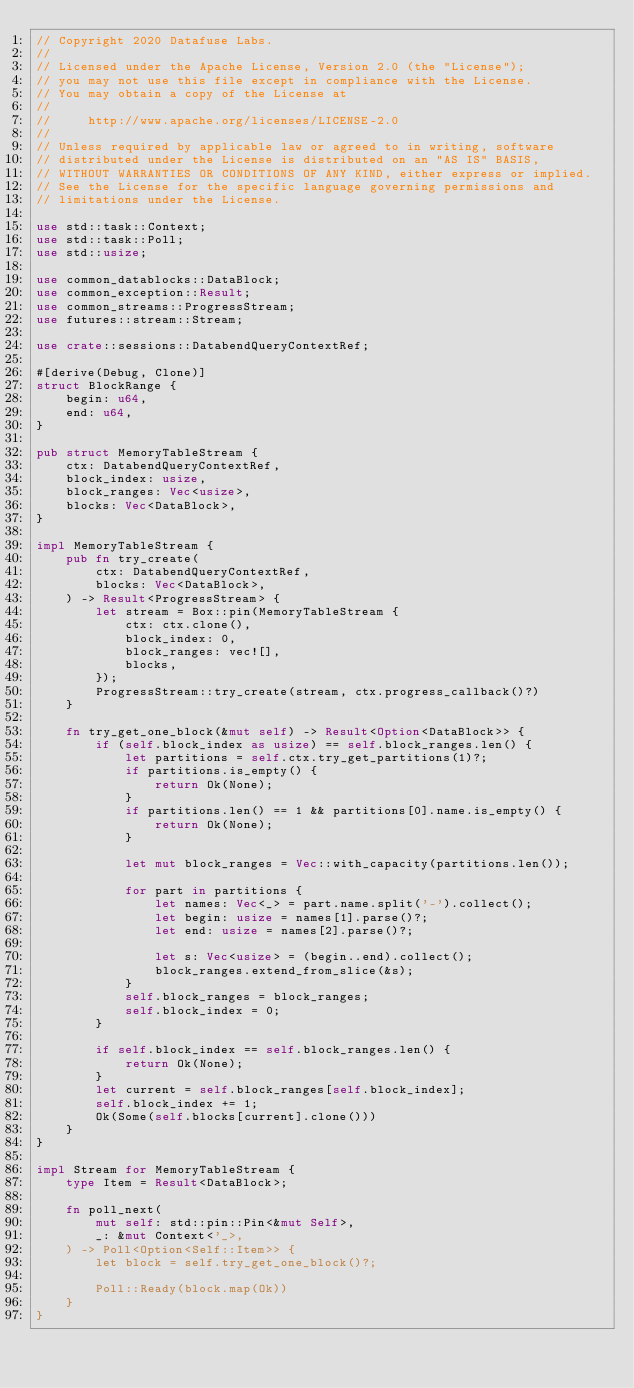Convert code to text. <code><loc_0><loc_0><loc_500><loc_500><_Rust_>// Copyright 2020 Datafuse Labs.
//
// Licensed under the Apache License, Version 2.0 (the "License");
// you may not use this file except in compliance with the License.
// You may obtain a copy of the License at
//
//     http://www.apache.org/licenses/LICENSE-2.0
//
// Unless required by applicable law or agreed to in writing, software
// distributed under the License is distributed on an "AS IS" BASIS,
// WITHOUT WARRANTIES OR CONDITIONS OF ANY KIND, either express or implied.
// See the License for the specific language governing permissions and
// limitations under the License.

use std::task::Context;
use std::task::Poll;
use std::usize;

use common_datablocks::DataBlock;
use common_exception::Result;
use common_streams::ProgressStream;
use futures::stream::Stream;

use crate::sessions::DatabendQueryContextRef;

#[derive(Debug, Clone)]
struct BlockRange {
    begin: u64,
    end: u64,
}

pub struct MemoryTableStream {
    ctx: DatabendQueryContextRef,
    block_index: usize,
    block_ranges: Vec<usize>,
    blocks: Vec<DataBlock>,
}

impl MemoryTableStream {
    pub fn try_create(
        ctx: DatabendQueryContextRef,
        blocks: Vec<DataBlock>,
    ) -> Result<ProgressStream> {
        let stream = Box::pin(MemoryTableStream {
            ctx: ctx.clone(),
            block_index: 0,
            block_ranges: vec![],
            blocks,
        });
        ProgressStream::try_create(stream, ctx.progress_callback()?)
    }

    fn try_get_one_block(&mut self) -> Result<Option<DataBlock>> {
        if (self.block_index as usize) == self.block_ranges.len() {
            let partitions = self.ctx.try_get_partitions(1)?;
            if partitions.is_empty() {
                return Ok(None);
            }
            if partitions.len() == 1 && partitions[0].name.is_empty() {
                return Ok(None);
            }

            let mut block_ranges = Vec::with_capacity(partitions.len());

            for part in partitions {
                let names: Vec<_> = part.name.split('-').collect();
                let begin: usize = names[1].parse()?;
                let end: usize = names[2].parse()?;

                let s: Vec<usize> = (begin..end).collect();
                block_ranges.extend_from_slice(&s);
            }
            self.block_ranges = block_ranges;
            self.block_index = 0;
        }

        if self.block_index == self.block_ranges.len() {
            return Ok(None);
        }
        let current = self.block_ranges[self.block_index];
        self.block_index += 1;
        Ok(Some(self.blocks[current].clone()))
    }
}

impl Stream for MemoryTableStream {
    type Item = Result<DataBlock>;

    fn poll_next(
        mut self: std::pin::Pin<&mut Self>,
        _: &mut Context<'_>,
    ) -> Poll<Option<Self::Item>> {
        let block = self.try_get_one_block()?;

        Poll::Ready(block.map(Ok))
    }
}
</code> 